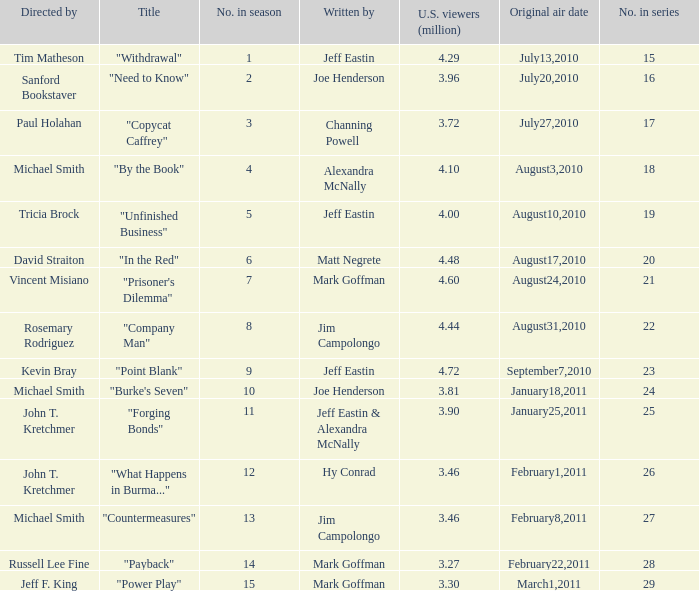Would you be able to parse every entry in this table? {'header': ['Directed by', 'Title', 'No. in season', 'Written by', 'U.S. viewers (million)', 'Original air date', 'No. in series'], 'rows': [['Tim Matheson', '"Withdrawal"', '1', 'Jeff Eastin', '4.29', 'July13,2010', '15'], ['Sanford Bookstaver', '"Need to Know"', '2', 'Joe Henderson', '3.96', 'July20,2010', '16'], ['Paul Holahan', '"Copycat Caffrey"', '3', 'Channing Powell', '3.72', 'July27,2010', '17'], ['Michael Smith', '"By the Book"', '4', 'Alexandra McNally', '4.10', 'August3,2010', '18'], ['Tricia Brock', '"Unfinished Business"', '5', 'Jeff Eastin', '4.00', 'August10,2010', '19'], ['David Straiton', '"In the Red"', '6', 'Matt Negrete', '4.48', 'August17,2010', '20'], ['Vincent Misiano', '"Prisoner\'s Dilemma"', '7', 'Mark Goffman', '4.60', 'August24,2010', '21'], ['Rosemary Rodriguez', '"Company Man"', '8', 'Jim Campolongo', '4.44', 'August31,2010', '22'], ['Kevin Bray', '"Point Blank"', '9', 'Jeff Eastin', '4.72', 'September7,2010', '23'], ['Michael Smith', '"Burke\'s Seven"', '10', 'Joe Henderson', '3.81', 'January18,2011', '24'], ['John T. Kretchmer', '"Forging Bonds"', '11', 'Jeff Eastin & Alexandra McNally', '3.90', 'January25,2011', '25'], ['John T. Kretchmer', '"What Happens in Burma..."', '12', 'Hy Conrad', '3.46', 'February1,2011', '26'], ['Michael Smith', '"Countermeasures"', '13', 'Jim Campolongo', '3.46', 'February8,2011', '27'], ['Russell Lee Fine', '"Payback"', '14', 'Mark Goffman', '3.27', 'February22,2011', '28'], ['Jeff F. King', '"Power Play"', '15', 'Mark Goffman', '3.30', 'March1,2011', '29']]} How many episodes in the season had 3.81 million US viewers? 1.0. 